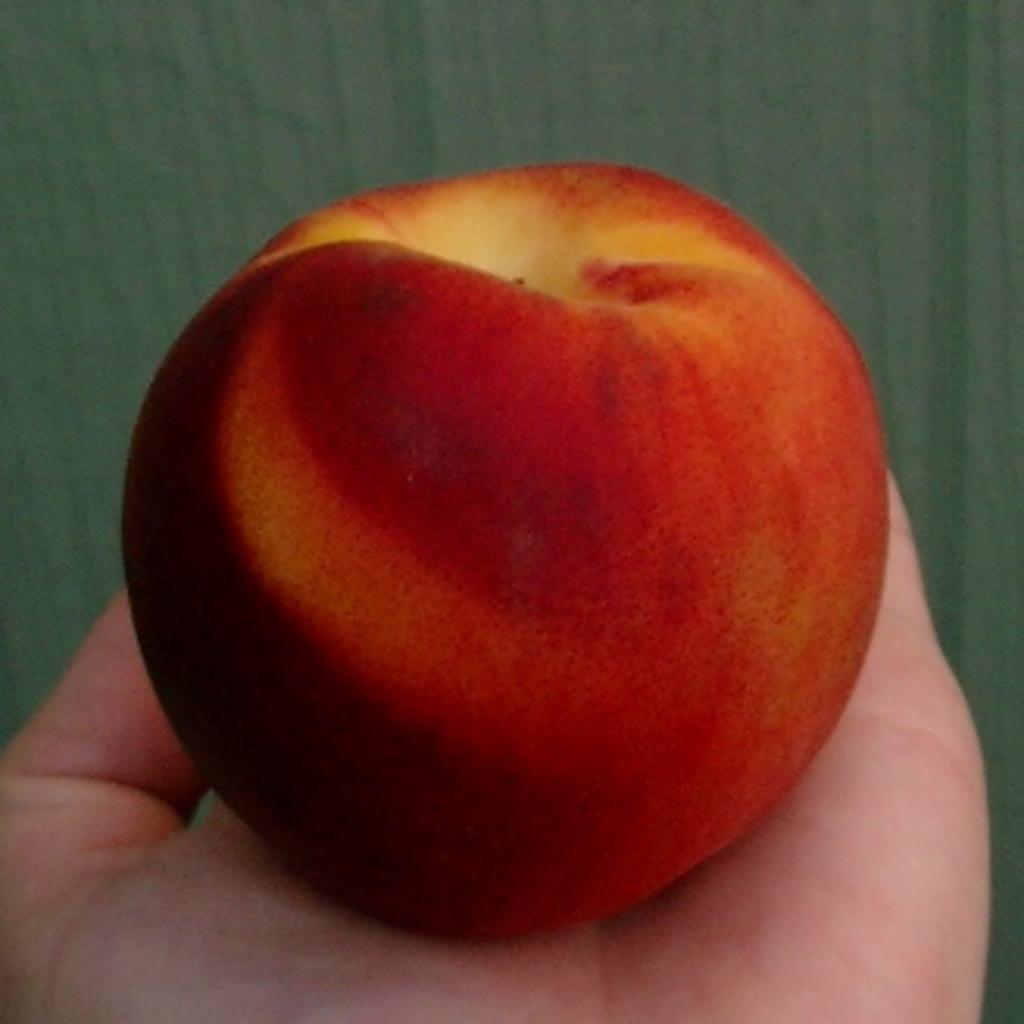How would you summarize this image in a sentence or two? In the picture,a person is holding an apple on his palm,the apple is of red and pale yellow color. 